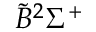<formula> <loc_0><loc_0><loc_500><loc_500>\widetilde { B } ^ { 2 } \Sigma ^ { + }</formula> 